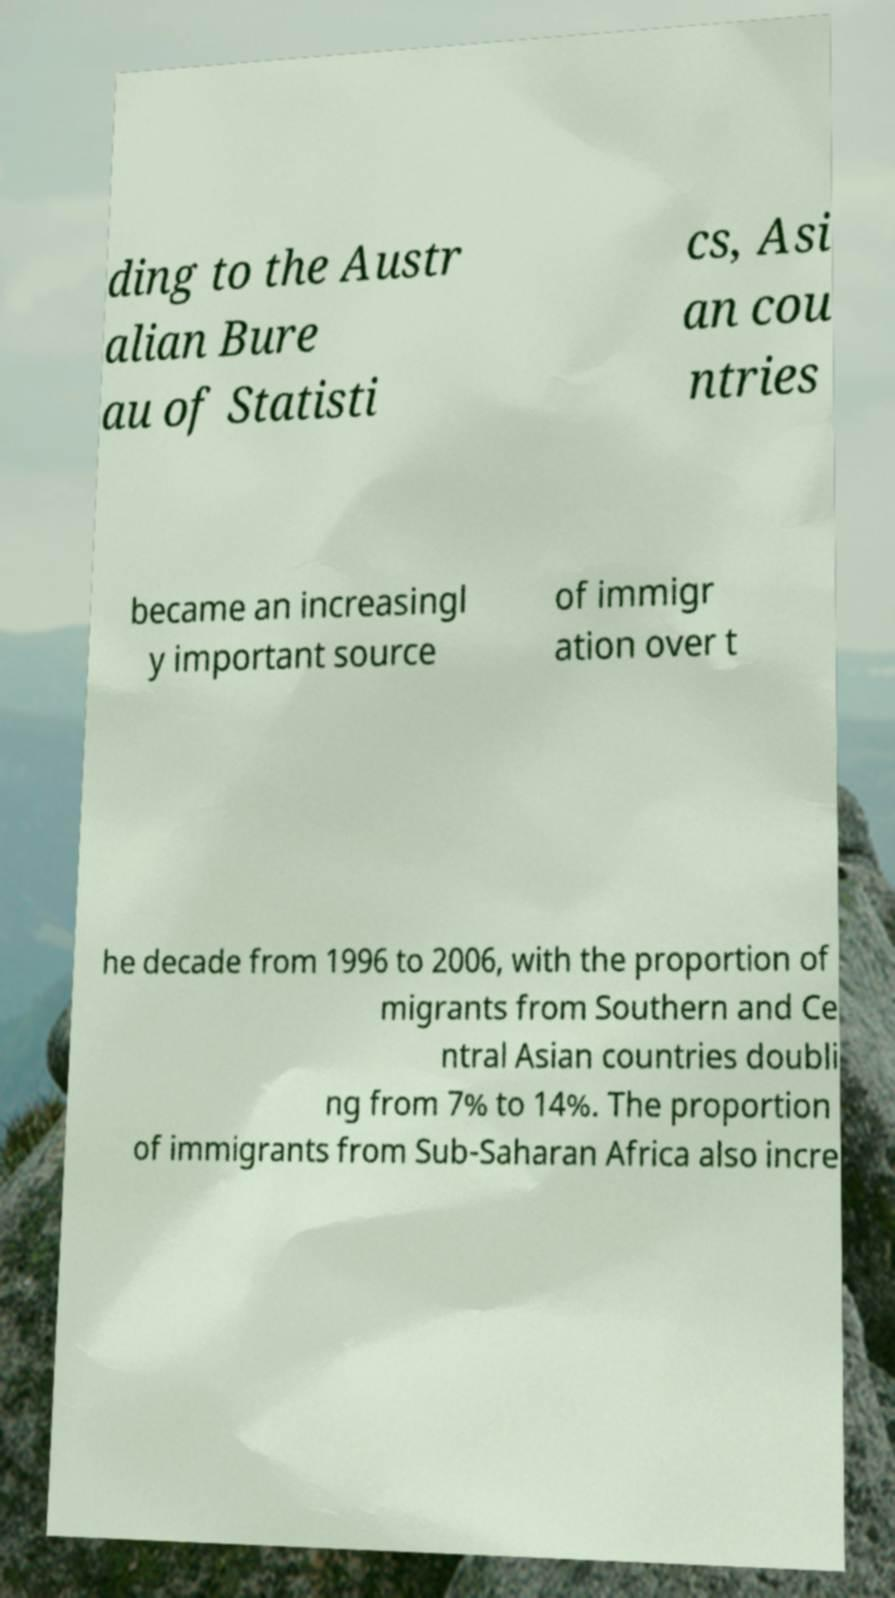Can you read and provide the text displayed in the image?This photo seems to have some interesting text. Can you extract and type it out for me? ding to the Austr alian Bure au of Statisti cs, Asi an cou ntries became an increasingl y important source of immigr ation over t he decade from 1996 to 2006, with the proportion of migrants from Southern and Ce ntral Asian countries doubli ng from 7% to 14%. The proportion of immigrants from Sub-Saharan Africa also incre 